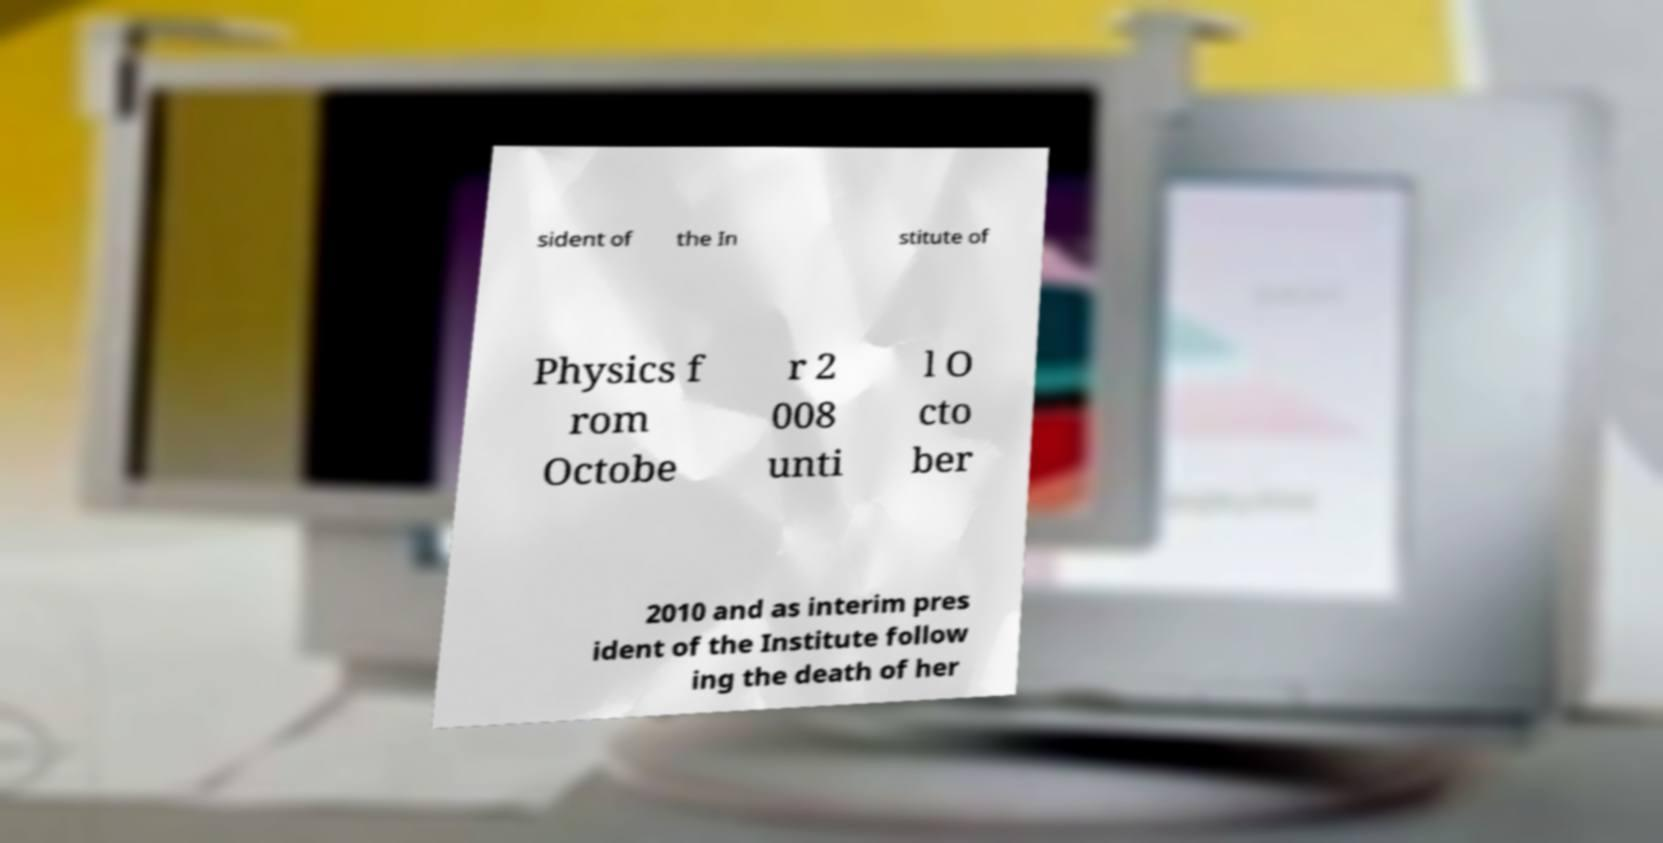For documentation purposes, I need the text within this image transcribed. Could you provide that? sident of the In stitute of Physics f rom Octobe r 2 008 unti l O cto ber 2010 and as interim pres ident of the Institute follow ing the death of her 